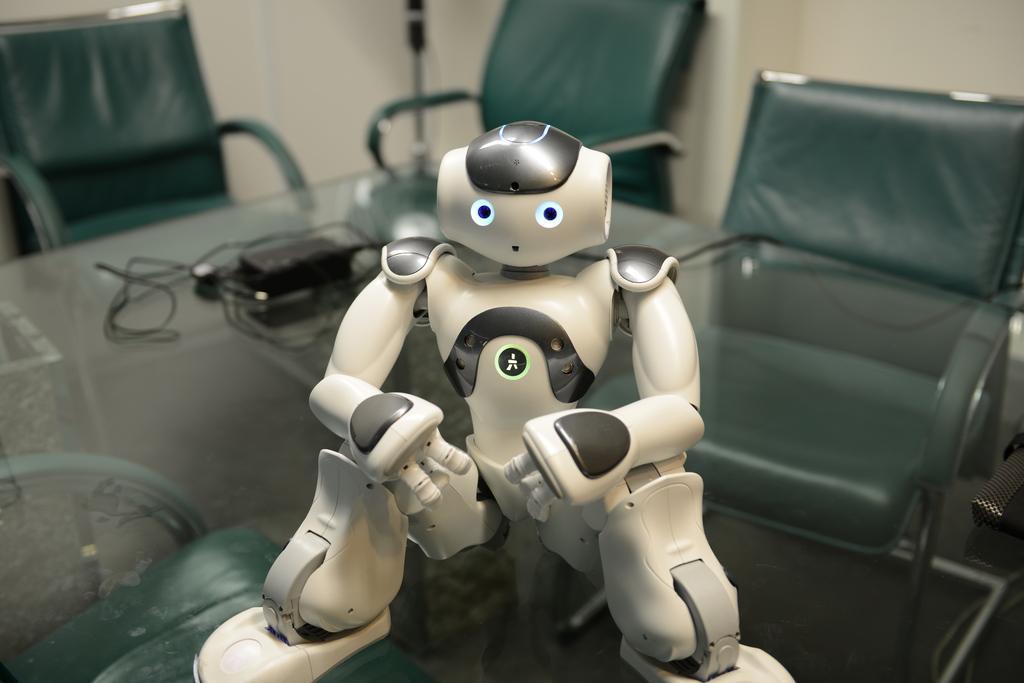Please provide a concise description of this image. On the background we can see wall. These are chairs near to the table. On the table we can see a robot and adapter. 